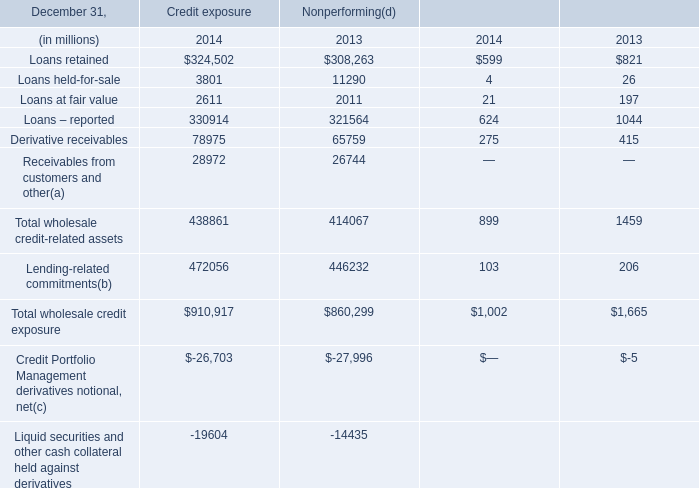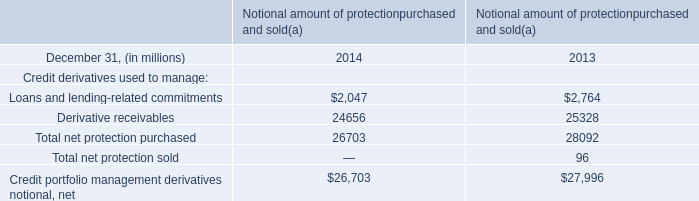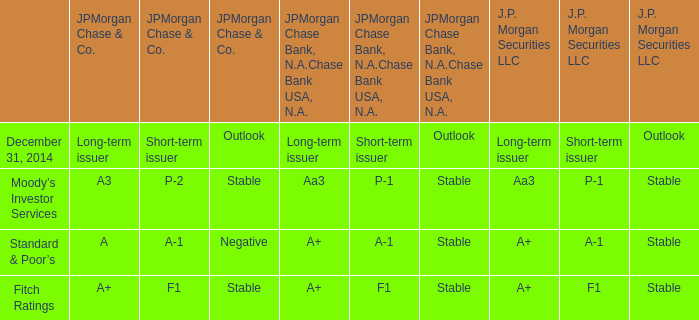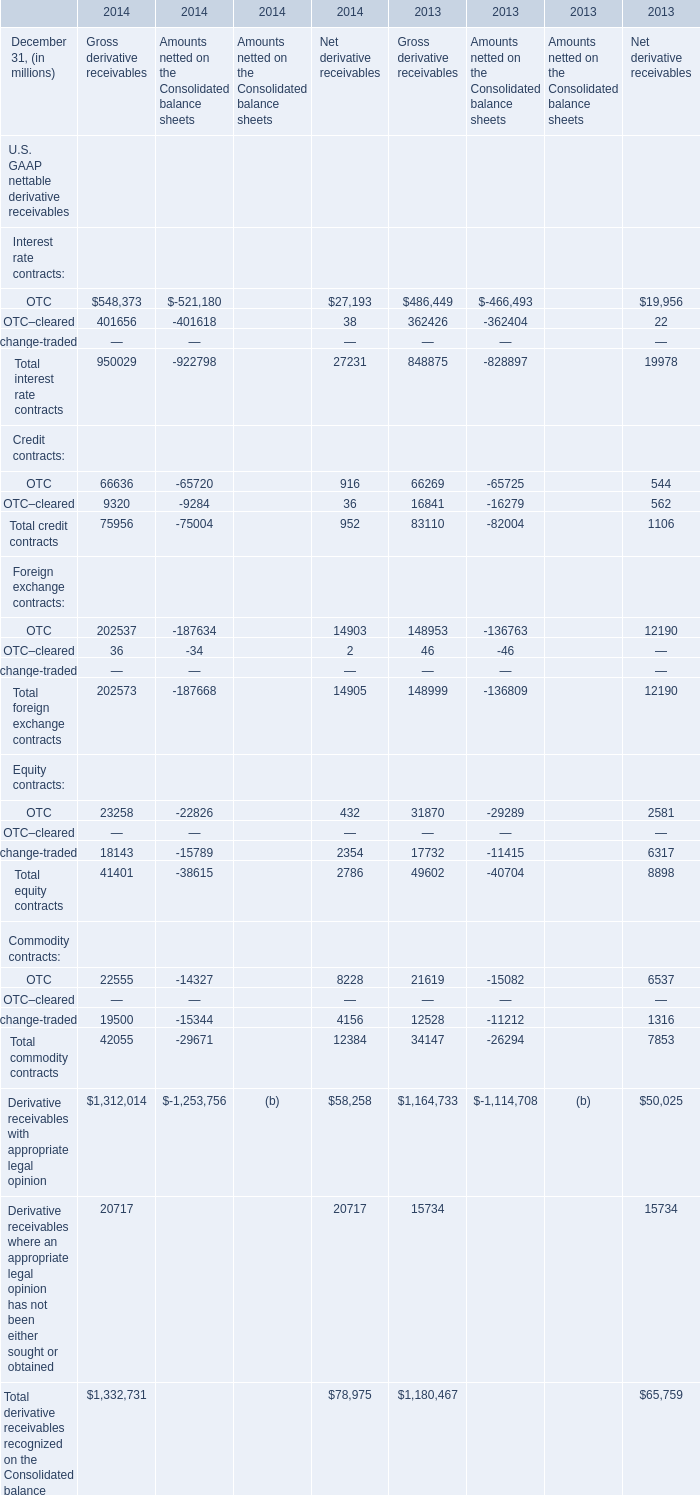In the section with the most OTC, what is the growth rate of OTC–cleared? 
Computations: ((401656 - 362426) / 401656)
Answer: 0.09767. 